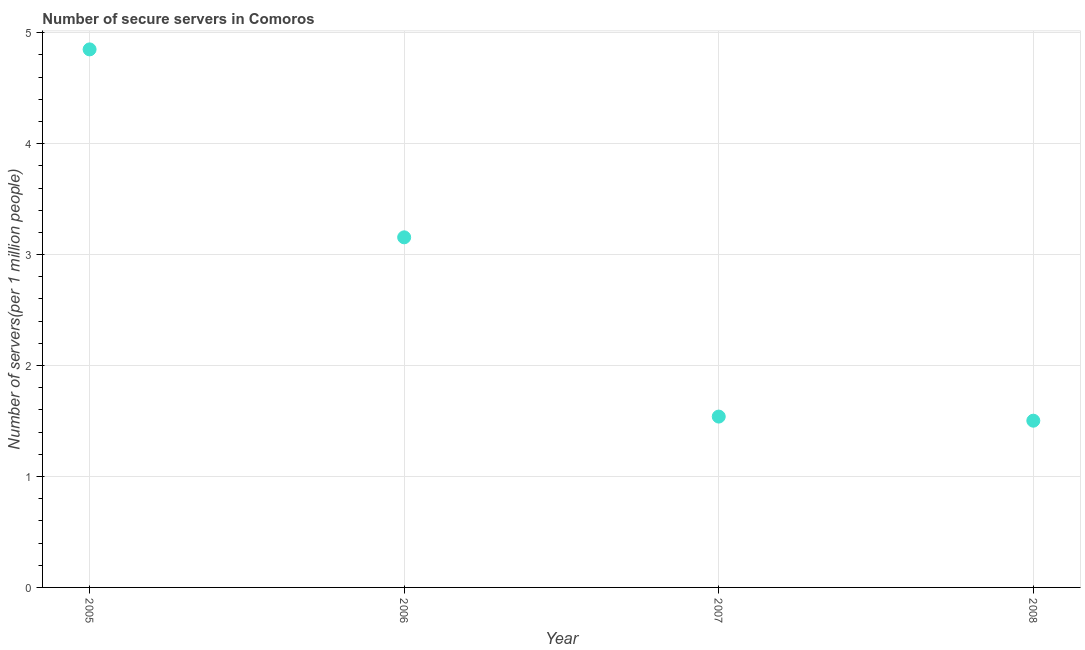What is the number of secure internet servers in 2008?
Provide a succinct answer. 1.5. Across all years, what is the maximum number of secure internet servers?
Your answer should be very brief. 4.85. Across all years, what is the minimum number of secure internet servers?
Give a very brief answer. 1.5. In which year was the number of secure internet servers maximum?
Your answer should be compact. 2005. In which year was the number of secure internet servers minimum?
Make the answer very short. 2008. What is the sum of the number of secure internet servers?
Offer a very short reply. 11.05. What is the difference between the number of secure internet servers in 2007 and 2008?
Make the answer very short. 0.04. What is the average number of secure internet servers per year?
Make the answer very short. 2.76. What is the median number of secure internet servers?
Your answer should be very brief. 2.35. Do a majority of the years between 2006 and 2005 (inclusive) have number of secure internet servers greater than 4 ?
Provide a short and direct response. No. What is the ratio of the number of secure internet servers in 2005 to that in 2008?
Provide a succinct answer. 3.23. What is the difference between the highest and the second highest number of secure internet servers?
Give a very brief answer. 1.69. What is the difference between the highest and the lowest number of secure internet servers?
Offer a very short reply. 3.35. How many years are there in the graph?
Provide a succinct answer. 4. What is the difference between two consecutive major ticks on the Y-axis?
Ensure brevity in your answer.  1. Are the values on the major ticks of Y-axis written in scientific E-notation?
Your response must be concise. No. Does the graph contain any zero values?
Make the answer very short. No. What is the title of the graph?
Your answer should be very brief. Number of secure servers in Comoros. What is the label or title of the Y-axis?
Offer a terse response. Number of servers(per 1 million people). What is the Number of servers(per 1 million people) in 2005?
Offer a terse response. 4.85. What is the Number of servers(per 1 million people) in 2006?
Your response must be concise. 3.16. What is the Number of servers(per 1 million people) in 2007?
Offer a very short reply. 1.54. What is the Number of servers(per 1 million people) in 2008?
Your answer should be compact. 1.5. What is the difference between the Number of servers(per 1 million people) in 2005 and 2006?
Give a very brief answer. 1.69. What is the difference between the Number of servers(per 1 million people) in 2005 and 2007?
Keep it short and to the point. 3.31. What is the difference between the Number of servers(per 1 million people) in 2005 and 2008?
Give a very brief answer. 3.35. What is the difference between the Number of servers(per 1 million people) in 2006 and 2007?
Provide a succinct answer. 1.62. What is the difference between the Number of servers(per 1 million people) in 2006 and 2008?
Your answer should be very brief. 1.65. What is the difference between the Number of servers(per 1 million people) in 2007 and 2008?
Ensure brevity in your answer.  0.04. What is the ratio of the Number of servers(per 1 million people) in 2005 to that in 2006?
Make the answer very short. 1.54. What is the ratio of the Number of servers(per 1 million people) in 2005 to that in 2007?
Ensure brevity in your answer.  3.15. What is the ratio of the Number of servers(per 1 million people) in 2005 to that in 2008?
Offer a terse response. 3.23. What is the ratio of the Number of servers(per 1 million people) in 2006 to that in 2007?
Make the answer very short. 2.05. What is the ratio of the Number of servers(per 1 million people) in 2007 to that in 2008?
Your response must be concise. 1.02. 